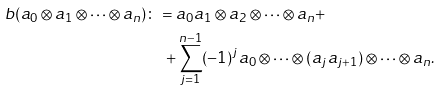<formula> <loc_0><loc_0><loc_500><loc_500>b ( a _ { 0 } \otimes a _ { 1 } \otimes \cdots \otimes a _ { n } ) & \colon = a _ { 0 } a _ { 1 } \otimes a _ { 2 } \otimes \cdots \otimes a _ { n } + \\ & \quad + \sum _ { j = 1 } ^ { n - 1 } ( - 1 ) ^ { j } a _ { 0 } \otimes \cdots \otimes ( a _ { j } a _ { j + 1 } ) \otimes \cdots \otimes a _ { n } .</formula> 